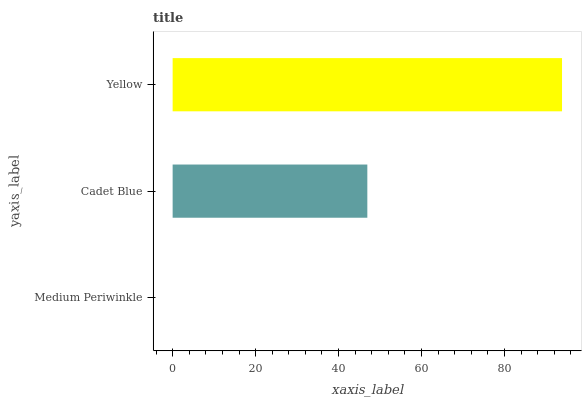Is Medium Periwinkle the minimum?
Answer yes or no. Yes. Is Yellow the maximum?
Answer yes or no. Yes. Is Cadet Blue the minimum?
Answer yes or no. No. Is Cadet Blue the maximum?
Answer yes or no. No. Is Cadet Blue greater than Medium Periwinkle?
Answer yes or no. Yes. Is Medium Periwinkle less than Cadet Blue?
Answer yes or no. Yes. Is Medium Periwinkle greater than Cadet Blue?
Answer yes or no. No. Is Cadet Blue less than Medium Periwinkle?
Answer yes or no. No. Is Cadet Blue the high median?
Answer yes or no. Yes. Is Cadet Blue the low median?
Answer yes or no. Yes. Is Yellow the high median?
Answer yes or no. No. Is Yellow the low median?
Answer yes or no. No. 